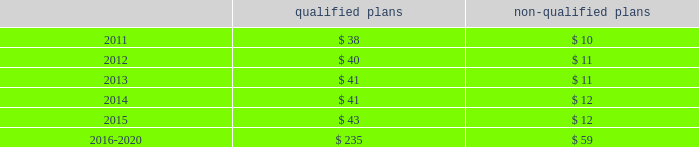Employee retirement plans 2013 ( continued ) of equities and fixed-income investments , and would be less liquid than financial instruments that trade on public markets .
Potential events or circumstances that could have a negative effect on estimated fair value include the risks of inadequate diversification and other operating risks .
To mitigate these risks , investments are diversified across and within asset classes in support of investment objectives .
Policies and practices to address operating risks include ongoing manager oversight , plan and asset class investment guidelines and instructions that are communicated to managers , and periodic compliance and audit reviews to ensure adherence to these policies .
In addition , the company periodically seeks the input of its independent advisor to ensure the investment policy is appropriate .
The company sponsors certain post-retirement benefit plans that provide medical , dental and life insurance coverage for eligible retirees and dependents in the united states based upon age and length of service .
The aggregate present value of the unfunded accumulated post-retirement benefit obligation was $ 13 million at both december 31 , 2010 and 2009 .
Cash flows at december 31 , 2010 , the company expected to contribute approximately $ 30 million to $ 35 million to its qualified defined-benefit pension plans to meet erisa requirements in 2011 .
The company also expected to pay benefits of $ 3 million and $ 10 million to participants of its unfunded foreign and non-qualified ( domestic ) defined-benefit pension plans , respectively , in 2011 .
At december 31 , 2010 , the benefits expected to be paid in each of the next five years , and in aggregate for the five years thereafter , relating to the company 2019s defined-benefit pension plans , were as follows , in millions : qualified non-qualified .
Shareholders 2019 equity in july 2007 , the company 2019s board of directors authorized the repurchase for retirement of up to 50 million shares of the company 2019s common stock in open-market transactions or otherwise .
At december 31 , 2010 , the company had remaining authorization to repurchase up to 27 million shares .
During 2010 , the company repurchased and retired three million shares of company common stock , for cash aggregating $ 45 million to offset the dilutive impact of the 2010 grant of three million shares of long-term stock awards .
The company repurchased and retired two million common shares in 2009 and nine million common shares in 2008 for cash aggregating $ 11 million and $ 160 million in 2009 and 2008 , respectively .
On the basis of amounts paid ( declared ) , cash dividends per common share were $ .30 ( $ .30 ) in 2010 , $ .46 ( $ .30 ) in 2009 and $ .925 ( $ .93 ) in 2008 , respectively .
In 2009 , the company decreased its quarterly cash dividend to $ .075 per common share from $ .235 per common share .
Masco corporation notes to consolidated financial statements 2014 ( continued ) .
In 2015 what was the ratio of the qualified plans to non-qualified plans? 
Rationale: in 2015 there was $ 3.6 qualified plans to the non-qualified plans
Computations: (43 / 12)
Answer: 3.58333. 